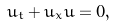Convert formula to latex. <formula><loc_0><loc_0><loc_500><loc_500>u _ { t } + u _ { x } u = 0 ,</formula> 